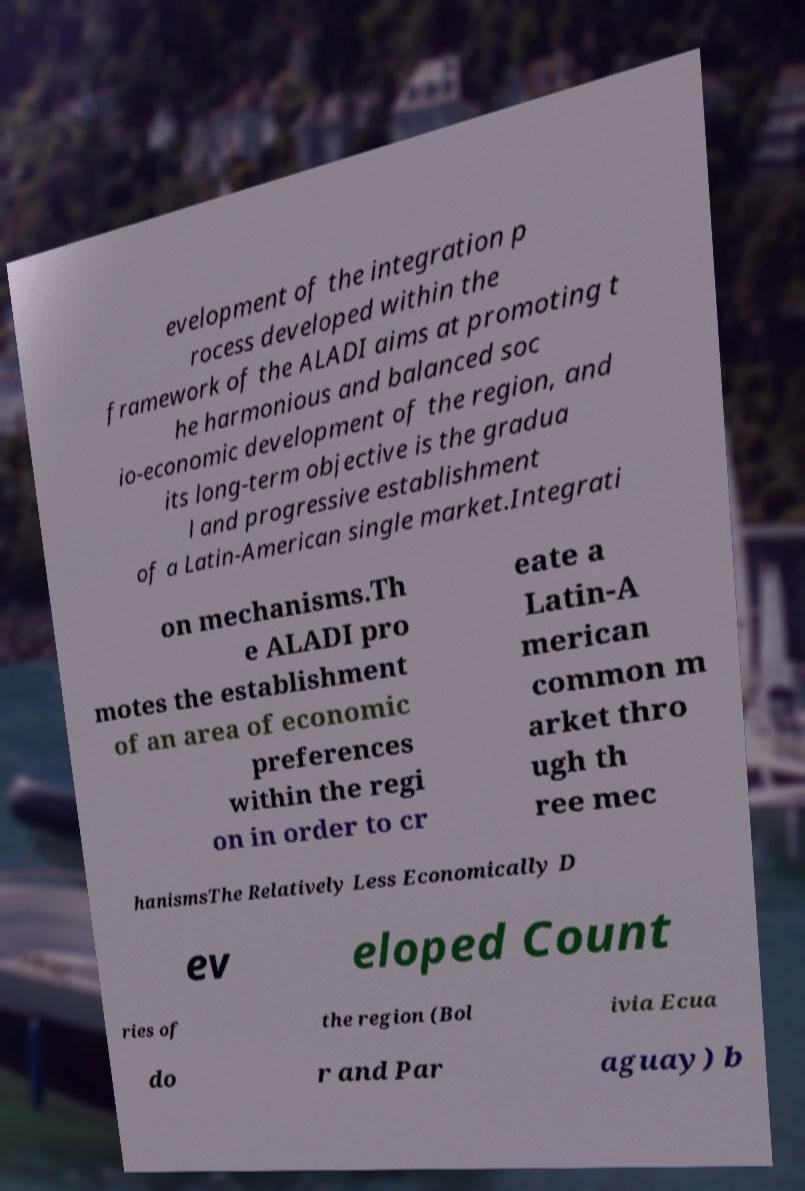Can you read and provide the text displayed in the image?This photo seems to have some interesting text. Can you extract and type it out for me? evelopment of the integration p rocess developed within the framework of the ALADI aims at promoting t he harmonious and balanced soc io-economic development of the region, and its long-term objective is the gradua l and progressive establishment of a Latin-American single market.Integrati on mechanisms.Th e ALADI pro motes the establishment of an area of economic preferences within the regi on in order to cr eate a Latin-A merican common m arket thro ugh th ree mec hanismsThe Relatively Less Economically D ev eloped Count ries of the region (Bol ivia Ecua do r and Par aguay) b 